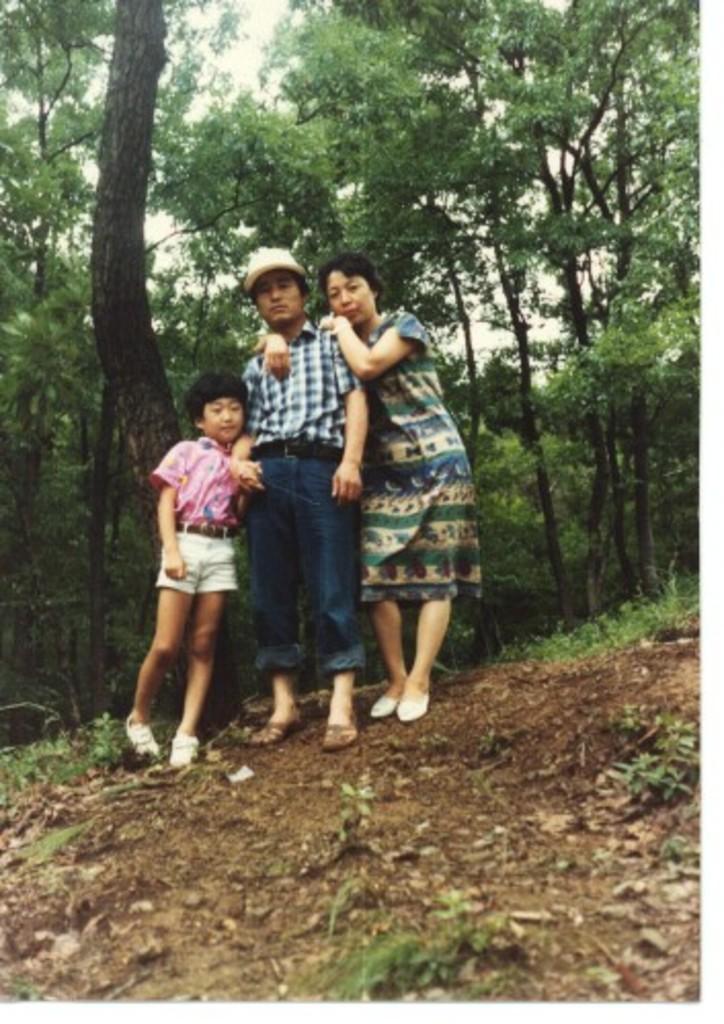Please provide a concise description of this image. In this picture we can see there are three people standing on the path and behind the people there are trees and a sky. 